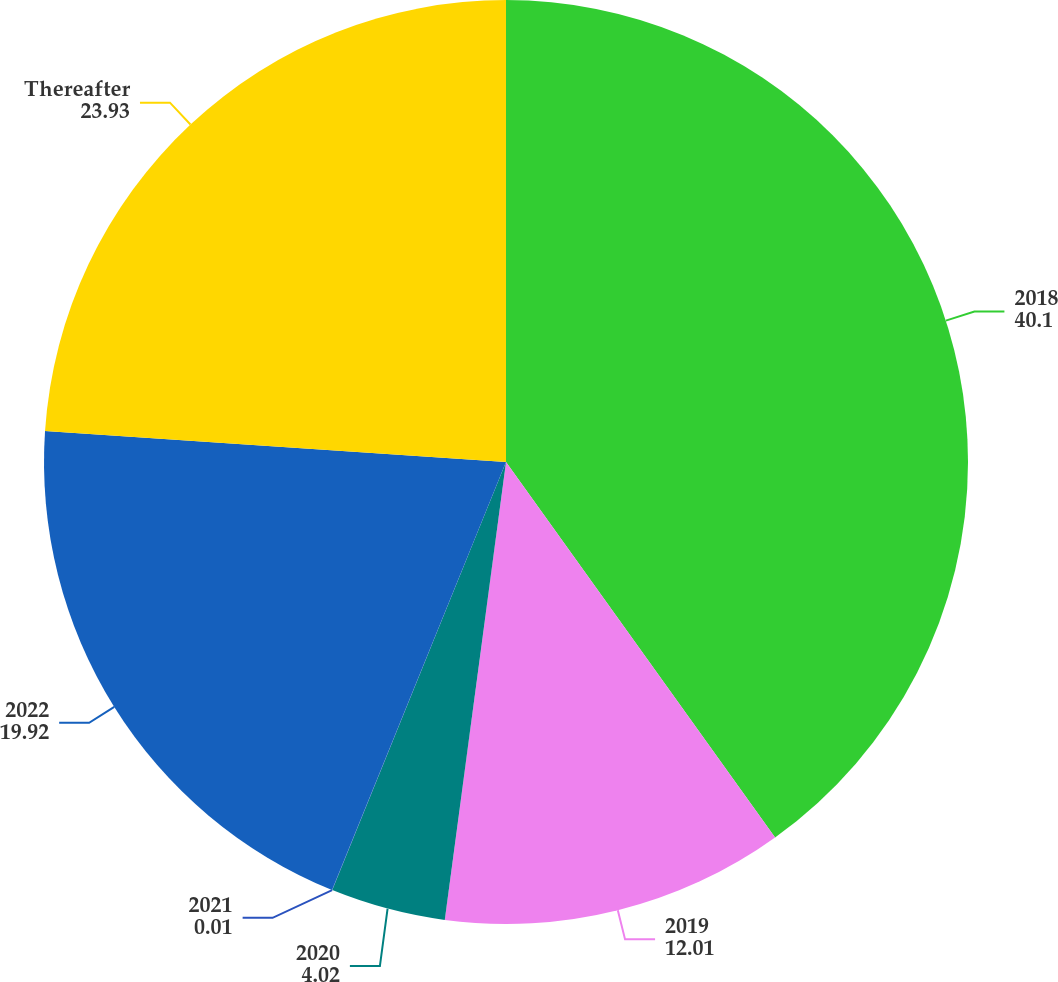Convert chart. <chart><loc_0><loc_0><loc_500><loc_500><pie_chart><fcel>2018<fcel>2019<fcel>2020<fcel>2021<fcel>2022<fcel>Thereafter<nl><fcel>40.1%<fcel>12.01%<fcel>4.02%<fcel>0.01%<fcel>19.92%<fcel>23.93%<nl></chart> 